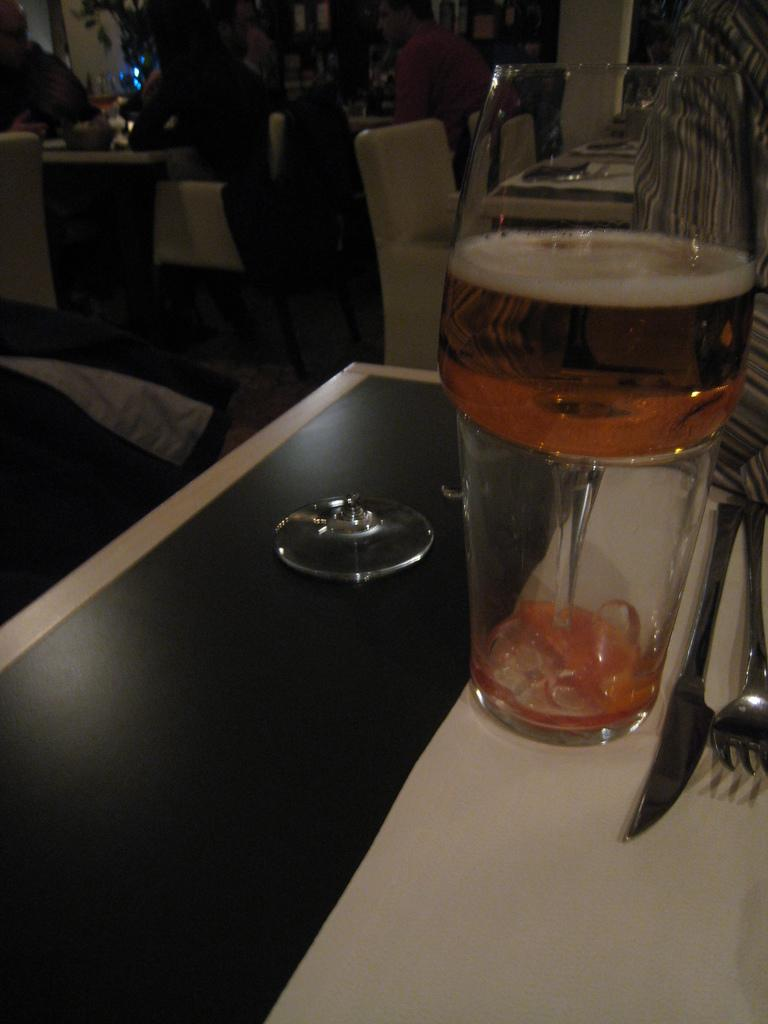What is placed on the table in the image? There is a glass and a fork on a table. Can you describe the setting where the glass and fork are located? The glass and fork are located on a table, which suggests it might be in a dining area. What can be seen in the background of the image? There is a group of people sitting in the background. What type of zinc is being used to cut the vegetables in the image? There is no zinc or cutting activity present in the image. Where are the scissors located in the image? There are no scissors present in the image. 